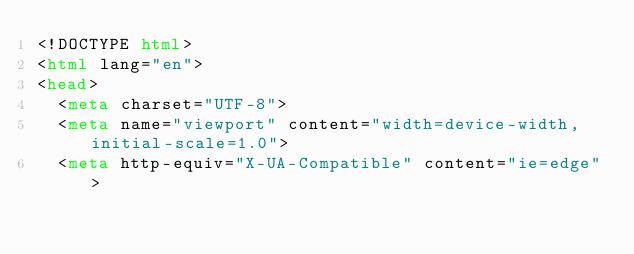Convert code to text. <code><loc_0><loc_0><loc_500><loc_500><_HTML_><!DOCTYPE html>
<html lang="en">
<head>
  <meta charset="UTF-8">
  <meta name="viewport" content="width=device-width, initial-scale=1.0">
  <meta http-equiv="X-UA-Compatible" content="ie=edge"></code> 